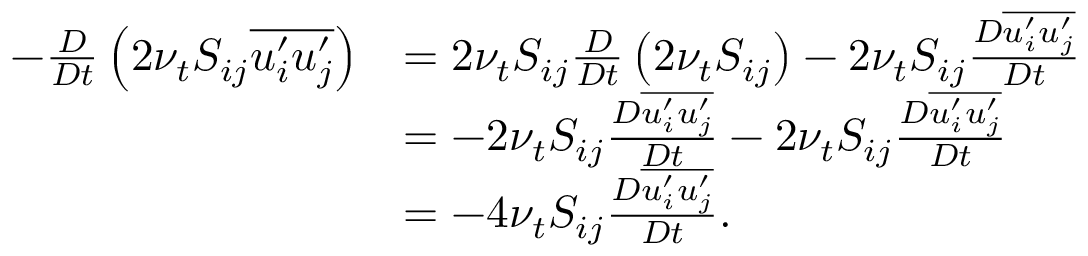<formula> <loc_0><loc_0><loc_500><loc_500>\begin{array} { r l } { - \frac { D } { D t } \left ( 2 \nu _ { t } S _ { i j } \overline { { u _ { i } ^ { \prime } u _ { j } ^ { \prime } } } \right ) } & { = 2 \nu _ { t } S _ { i j } \frac { D } { D t } \left ( 2 \nu _ { t } S _ { i j } \right ) - 2 \nu _ { t } S _ { i j } \frac { D \overline { { u _ { i } ^ { \prime } u _ { j } ^ { \prime } } } } { D t } } \\ & { = - 2 \nu _ { t } S _ { i j } \frac { D \overline { { u _ { i } ^ { \prime } u _ { j } ^ { \prime } } } } { D t } - 2 \nu _ { t } S _ { i j } \frac { D \overline { { u _ { i } ^ { \prime } u _ { j } ^ { \prime } } } } { D t } } \\ & { = - 4 \nu _ { t } S _ { i j } \frac { D \overline { { u _ { i } ^ { \prime } u _ { j } ^ { \prime } } } } { D t } . } \end{array}</formula> 